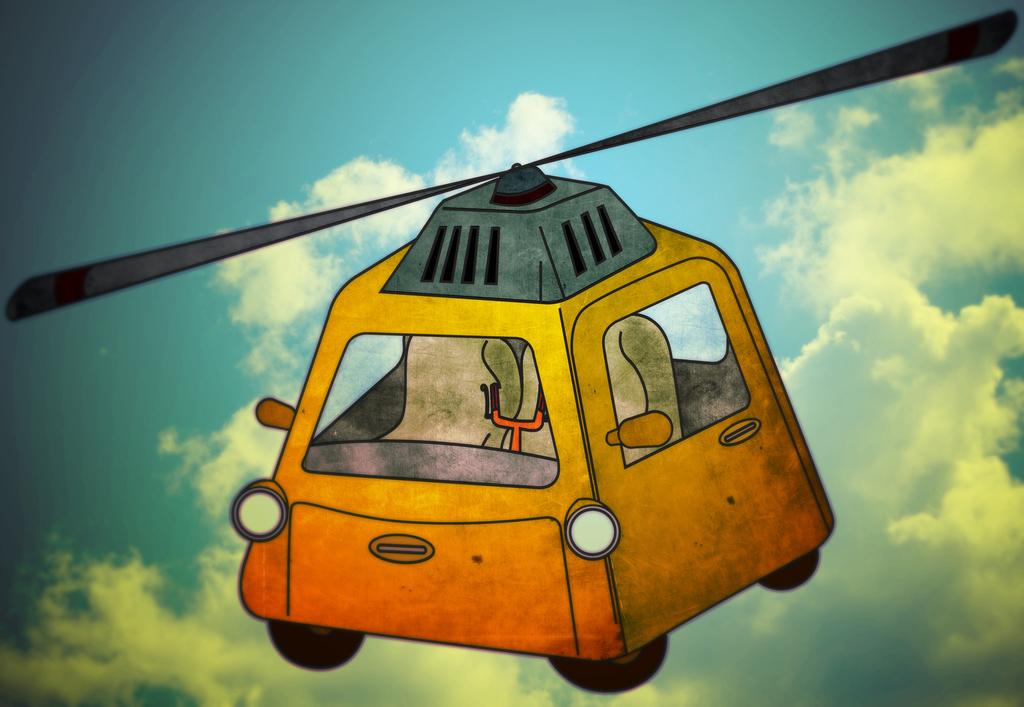What is the main subject of the image? There is a depiction of a vehicle in the image. Can you describe the background of the image? There are clouds visible in the background of the image. How many roses can be seen growing in the land depicted in the image? There are no roses or land visible in the image; it features a vehicle and clouds in the background. 